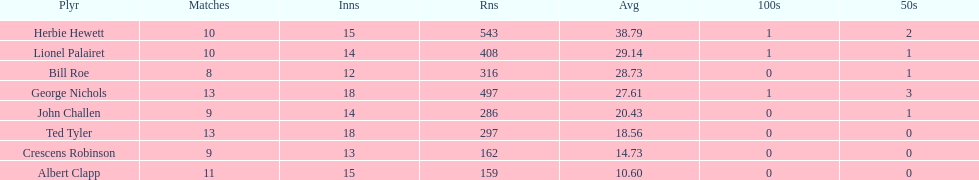Name a player that play in no more than 13 innings. Bill Roe. 